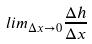<formula> <loc_0><loc_0><loc_500><loc_500>l i m _ { \Delta x \rightarrow 0 } \frac { \Delta h } { \Delta x }</formula> 